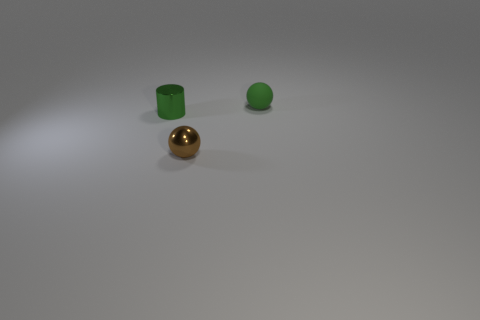Add 2 green metal cylinders. How many objects exist? 5 Subtract all green balls. How many balls are left? 1 Subtract all balls. How many objects are left? 1 Subtract 0 brown blocks. How many objects are left? 3 Subtract all gray spheres. Subtract all cyan blocks. How many spheres are left? 2 Subtract all large green shiny cylinders. Subtract all green cylinders. How many objects are left? 2 Add 3 shiny cylinders. How many shiny cylinders are left? 4 Add 2 rubber balls. How many rubber balls exist? 3 